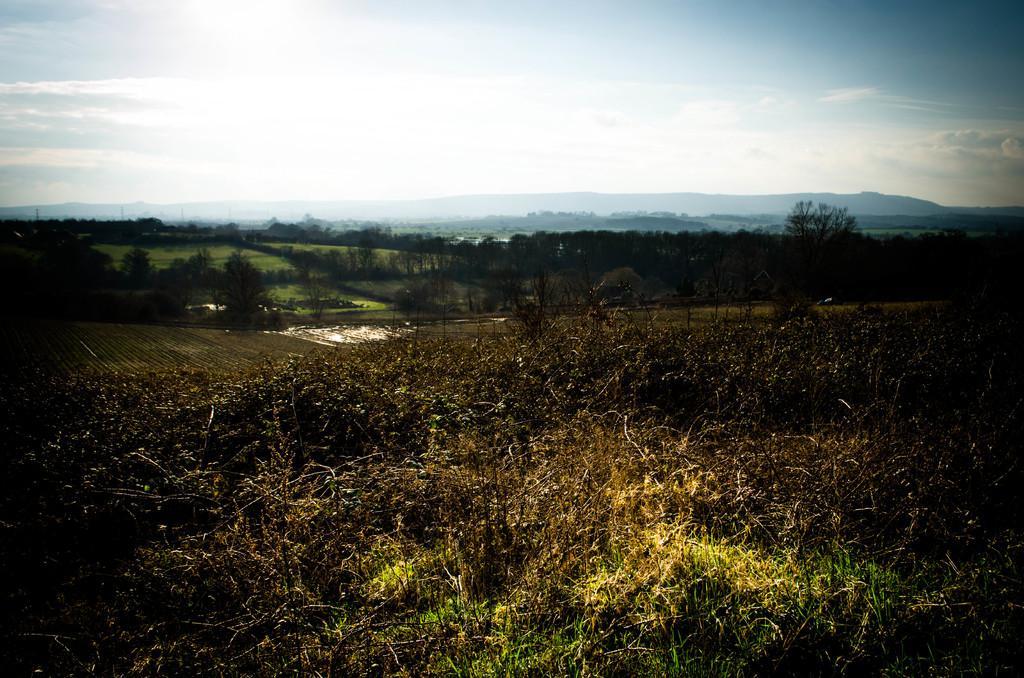Please provide a concise description of this image. In this picture I can see grass, there are trees, hills, and in the background there is the sky. 